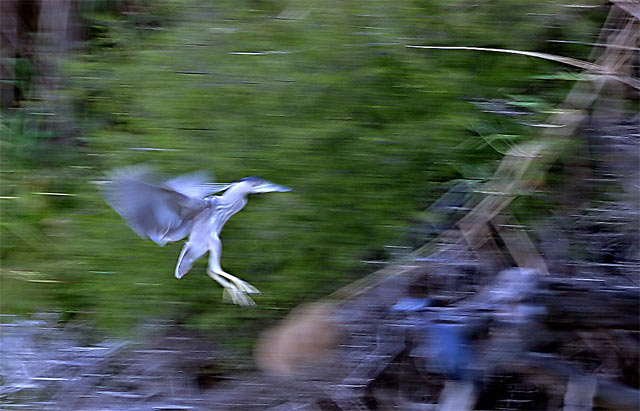Could you describe the technique used to capture this image? The technique used here is likely known as panning. It involves moving the camera along with the subject in motion to keep it in focus, while the slower shutter speed allows the background to blur, emphasizing the speed of the bird's flight. 